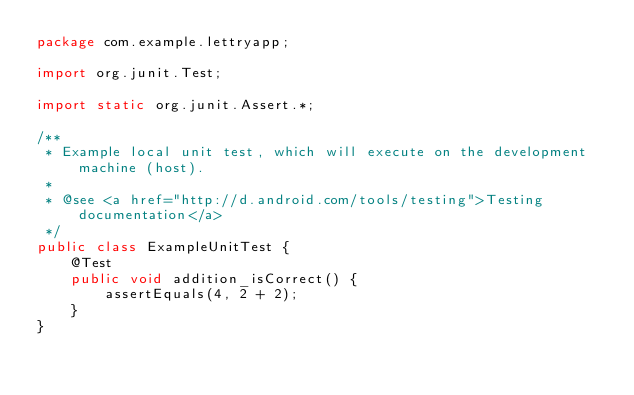<code> <loc_0><loc_0><loc_500><loc_500><_Java_>package com.example.lettryapp;

import org.junit.Test;

import static org.junit.Assert.*;

/**
 * Example local unit test, which will execute on the development machine (host).
 *
 * @see <a href="http://d.android.com/tools/testing">Testing documentation</a>
 */
public class ExampleUnitTest {
    @Test
    public void addition_isCorrect() {
        assertEquals(4, 2 + 2);
    }
}</code> 